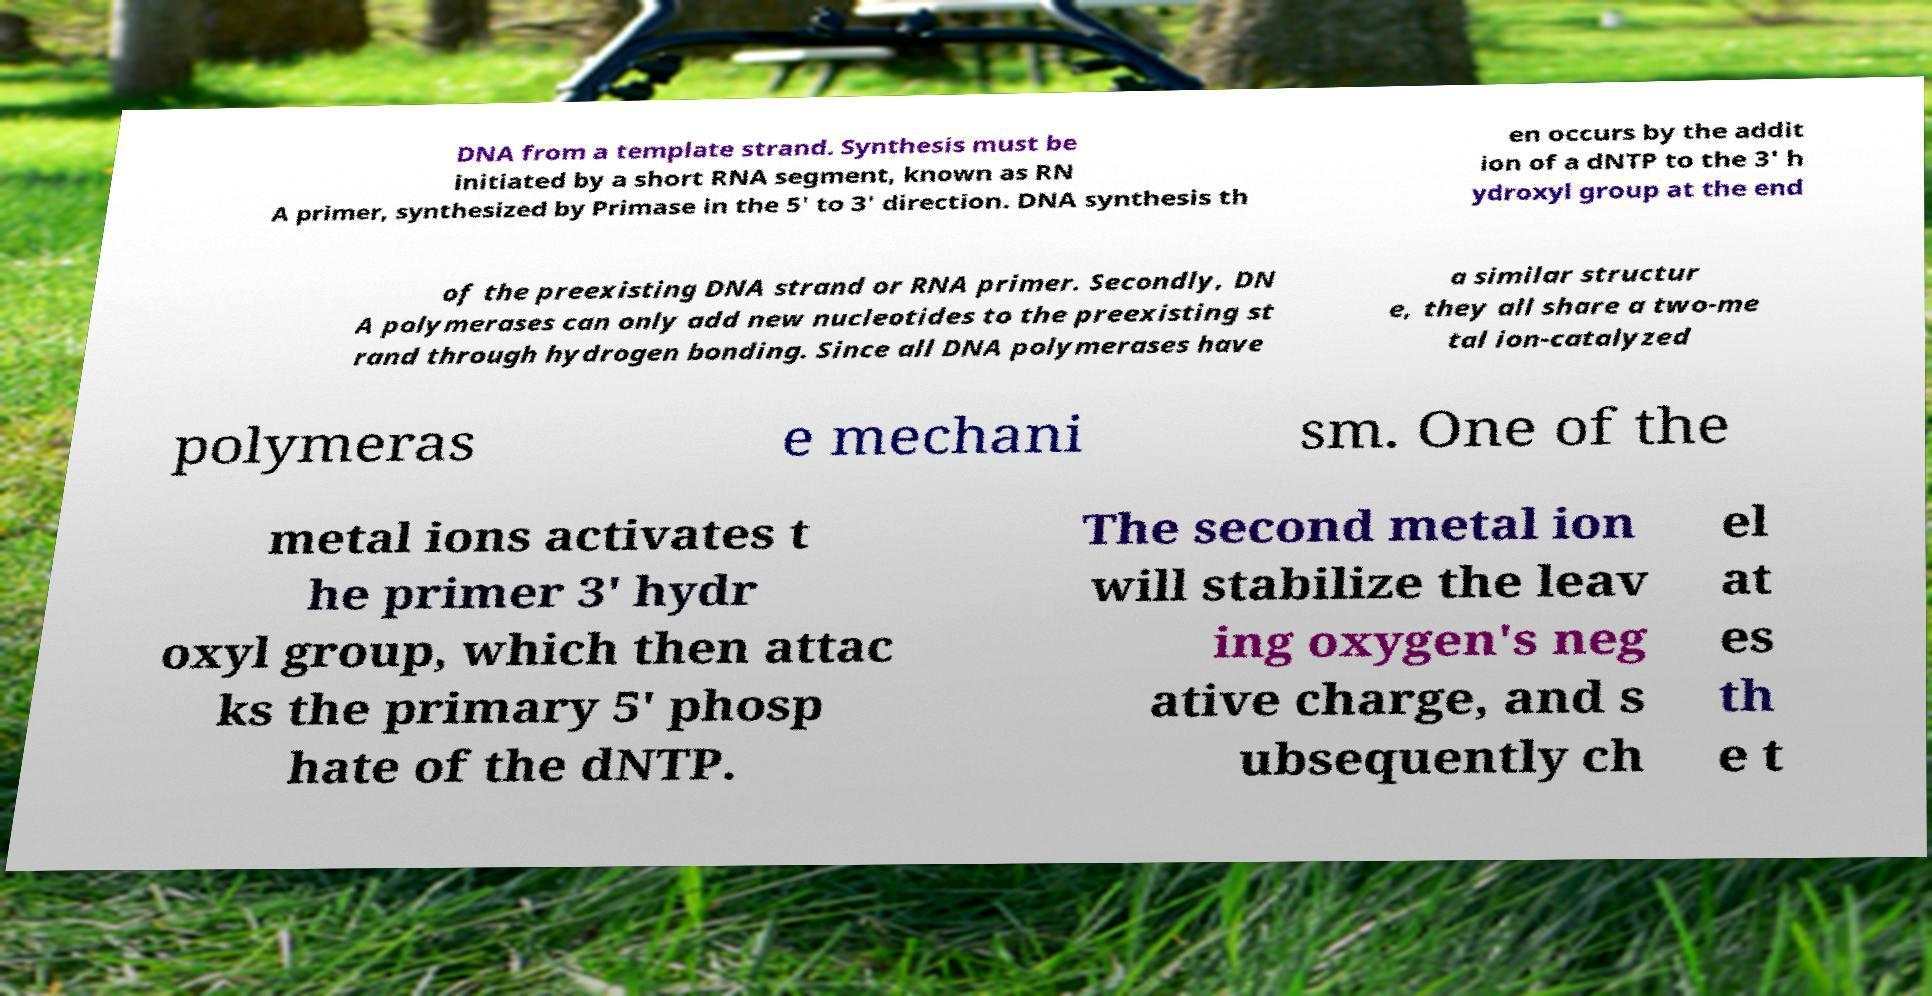Could you assist in decoding the text presented in this image and type it out clearly? DNA from a template strand. Synthesis must be initiated by a short RNA segment, known as RN A primer, synthesized by Primase in the 5' to 3' direction. DNA synthesis th en occurs by the addit ion of a dNTP to the 3' h ydroxyl group at the end of the preexisting DNA strand or RNA primer. Secondly, DN A polymerases can only add new nucleotides to the preexisting st rand through hydrogen bonding. Since all DNA polymerases have a similar structur e, they all share a two-me tal ion-catalyzed polymeras e mechani sm. One of the metal ions activates t he primer 3' hydr oxyl group, which then attac ks the primary 5' phosp hate of the dNTP. The second metal ion will stabilize the leav ing oxygen's neg ative charge, and s ubsequently ch el at es th e t 